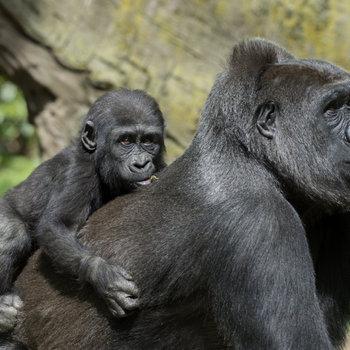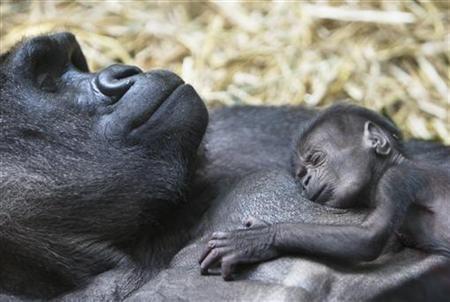The first image is the image on the left, the second image is the image on the right. For the images shown, is this caption "A baby primate lies on an adult in each of the images." true? Answer yes or no. Yes. The first image is the image on the left, the second image is the image on the right. Examine the images to the left and right. Is the description "A baby gorilla is clinging to the chest of an adult gorilla in one image, and the other image includes at least one baby gorilla in a different position [than the aforementioned image]." accurate? Answer yes or no. Yes. 